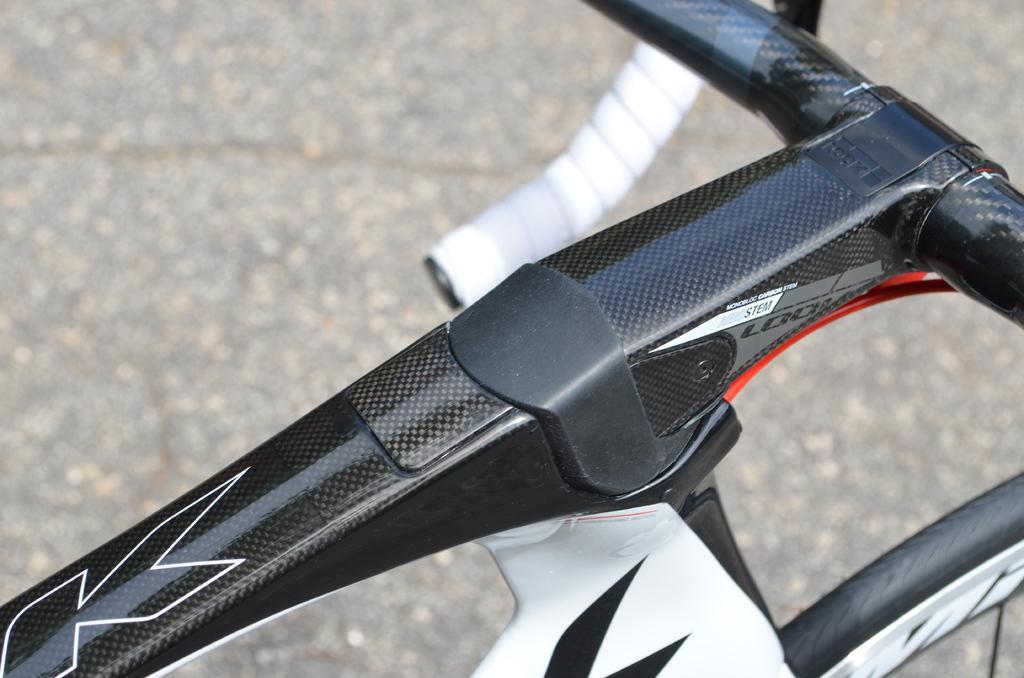Can you describe this image briefly? This image is taken outdoors. In the background there is a road. At the bottom of the image there is a bicycle parked on the road. 